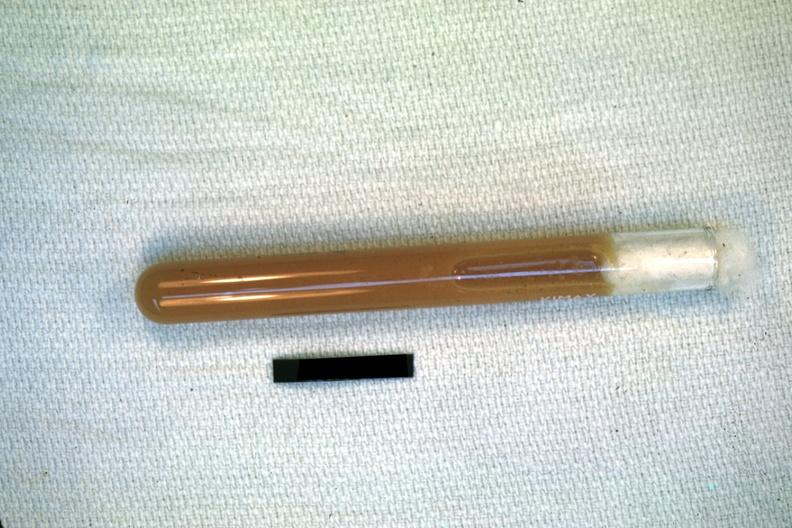s tuberculous peritonitis present?
Answer the question using a single word or phrase. No 